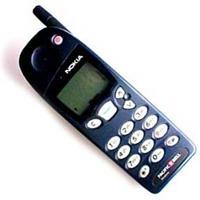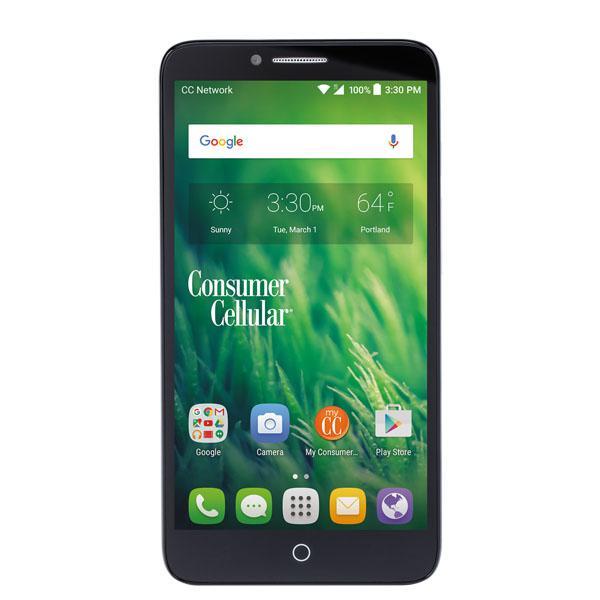The first image is the image on the left, the second image is the image on the right. Examine the images to the left and right. Is the description "One phone is white around the screen." accurate? Answer yes or no. No. The first image is the image on the left, the second image is the image on the right. For the images shown, is this caption "One image shows a flat phone with a big screen displayed head-on and vertically, and the other image includes a phone with an antenna that is displayed at an angle." true? Answer yes or no. Yes. 